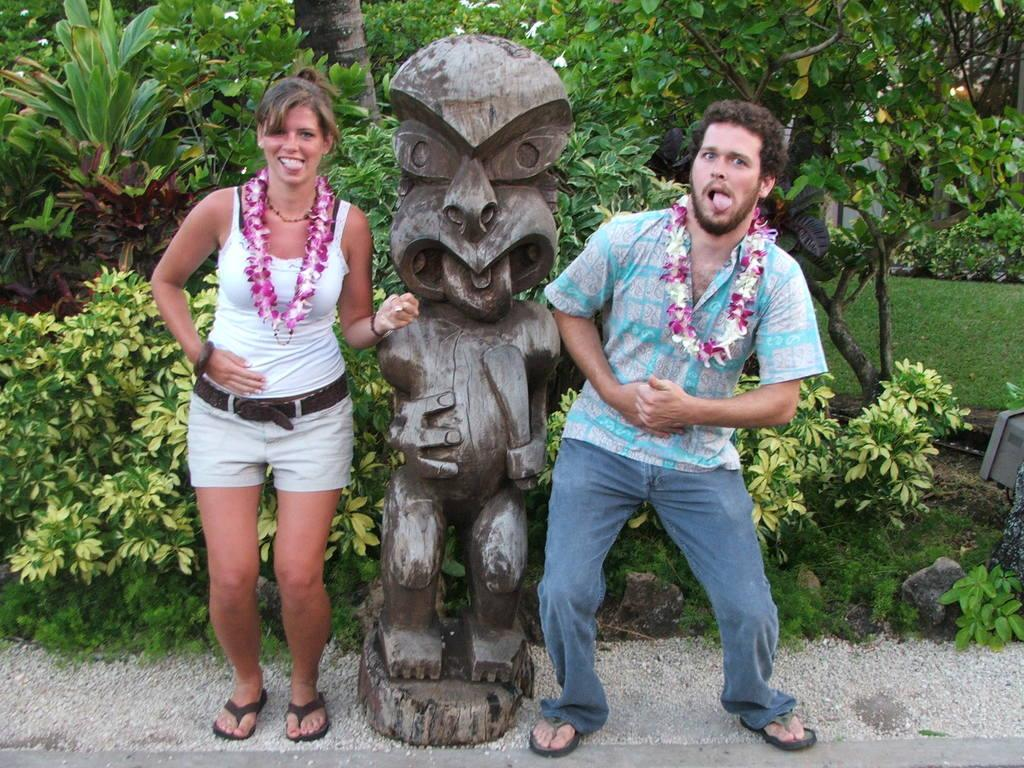How many people are present in the image? There is a man and a woman in the image. What is located in the middle of the image? There is a statue in the middle of the image. What type of vegetation can be seen in the background of the image? There are plants, trees, and grass in the background of the image. What is present at the bottom of the image? There are stones at the bottom of the image. What type of feather can be seen on the woman's hat in the image? There is no feather present on the woman's hat in the image. How many family members are present in the image? The image only shows a man and a woman, so it is not possible to determine the number of family members. 